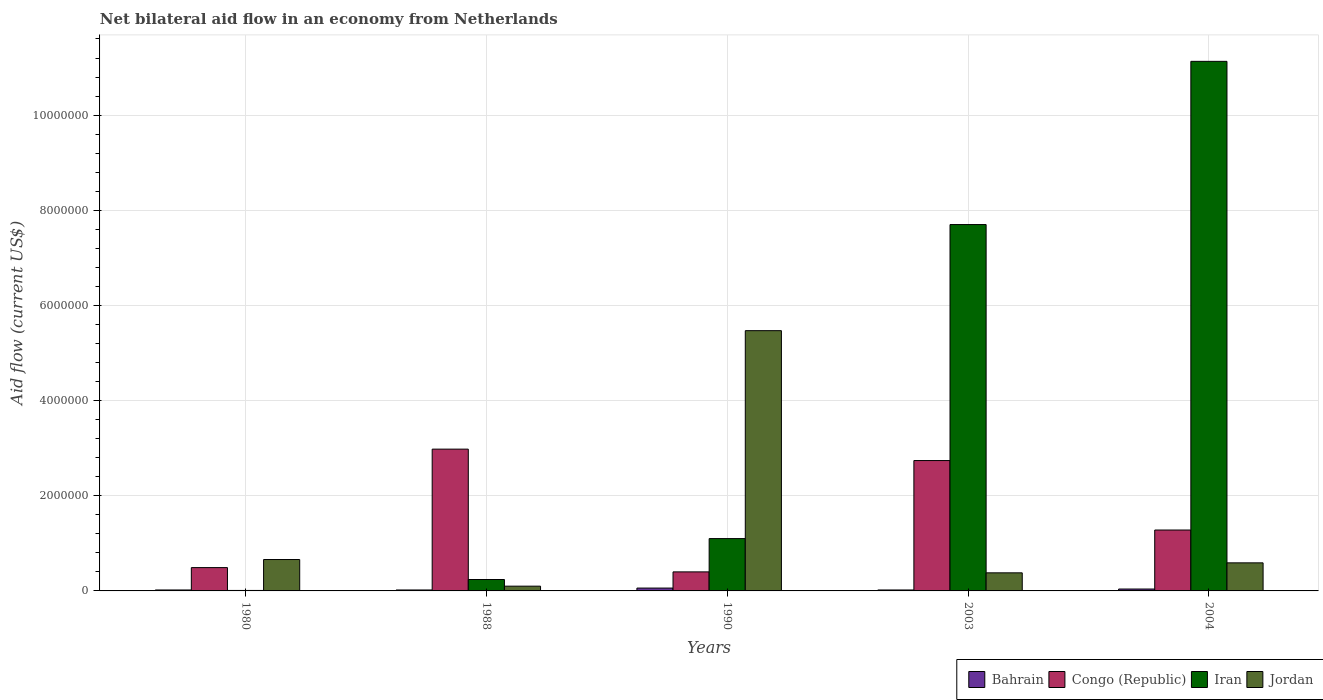How many different coloured bars are there?
Offer a terse response. 4. What is the net bilateral aid flow in Congo (Republic) in 2004?
Make the answer very short. 1.28e+06. Across all years, what is the maximum net bilateral aid flow in Congo (Republic)?
Ensure brevity in your answer.  2.98e+06. Across all years, what is the minimum net bilateral aid flow in Jordan?
Your response must be concise. 1.00e+05. In which year was the net bilateral aid flow in Iran maximum?
Keep it short and to the point. 2004. In which year was the net bilateral aid flow in Jordan minimum?
Give a very brief answer. 1988. What is the total net bilateral aid flow in Jordan in the graph?
Your answer should be very brief. 7.20e+06. What is the difference between the net bilateral aid flow in Jordan in 1990 and that in 2004?
Your answer should be very brief. 4.88e+06. What is the difference between the net bilateral aid flow in Iran in 1980 and the net bilateral aid flow in Jordan in 1990?
Offer a very short reply. -5.46e+06. What is the average net bilateral aid flow in Congo (Republic) per year?
Your response must be concise. 1.58e+06. In the year 2004, what is the difference between the net bilateral aid flow in Congo (Republic) and net bilateral aid flow in Bahrain?
Make the answer very short. 1.24e+06. What is the ratio of the net bilateral aid flow in Jordan in 1988 to that in 1990?
Your answer should be compact. 0.02. What is the difference between the highest and the second highest net bilateral aid flow in Jordan?
Offer a very short reply. 4.81e+06. What is the difference between the highest and the lowest net bilateral aid flow in Jordan?
Provide a succinct answer. 5.37e+06. In how many years, is the net bilateral aid flow in Bahrain greater than the average net bilateral aid flow in Bahrain taken over all years?
Offer a terse response. 2. Is the sum of the net bilateral aid flow in Congo (Republic) in 2003 and 2004 greater than the maximum net bilateral aid flow in Iran across all years?
Your response must be concise. No. What does the 2nd bar from the left in 2004 represents?
Your response must be concise. Congo (Republic). What does the 4th bar from the right in 1988 represents?
Your answer should be very brief. Bahrain. Is it the case that in every year, the sum of the net bilateral aid flow in Iran and net bilateral aid flow in Congo (Republic) is greater than the net bilateral aid flow in Bahrain?
Your answer should be very brief. Yes. How many bars are there?
Keep it short and to the point. 20. How many years are there in the graph?
Your response must be concise. 5. What is the difference between two consecutive major ticks on the Y-axis?
Your answer should be very brief. 2.00e+06. How many legend labels are there?
Your answer should be compact. 4. How are the legend labels stacked?
Provide a succinct answer. Horizontal. What is the title of the graph?
Provide a short and direct response. Net bilateral aid flow in an economy from Netherlands. What is the Aid flow (current US$) of Congo (Republic) in 1988?
Offer a terse response. 2.98e+06. What is the Aid flow (current US$) of Jordan in 1988?
Provide a succinct answer. 1.00e+05. What is the Aid flow (current US$) of Bahrain in 1990?
Your response must be concise. 6.00e+04. What is the Aid flow (current US$) of Iran in 1990?
Offer a very short reply. 1.10e+06. What is the Aid flow (current US$) of Jordan in 1990?
Keep it short and to the point. 5.47e+06. What is the Aid flow (current US$) of Congo (Republic) in 2003?
Offer a terse response. 2.74e+06. What is the Aid flow (current US$) of Iran in 2003?
Offer a terse response. 7.70e+06. What is the Aid flow (current US$) in Bahrain in 2004?
Your answer should be compact. 4.00e+04. What is the Aid flow (current US$) in Congo (Republic) in 2004?
Offer a very short reply. 1.28e+06. What is the Aid flow (current US$) in Iran in 2004?
Offer a terse response. 1.11e+07. What is the Aid flow (current US$) of Jordan in 2004?
Ensure brevity in your answer.  5.90e+05. Across all years, what is the maximum Aid flow (current US$) in Bahrain?
Provide a short and direct response. 6.00e+04. Across all years, what is the maximum Aid flow (current US$) of Congo (Republic)?
Offer a terse response. 2.98e+06. Across all years, what is the maximum Aid flow (current US$) in Iran?
Keep it short and to the point. 1.11e+07. Across all years, what is the maximum Aid flow (current US$) in Jordan?
Give a very brief answer. 5.47e+06. Across all years, what is the minimum Aid flow (current US$) in Congo (Republic)?
Keep it short and to the point. 4.00e+05. Across all years, what is the minimum Aid flow (current US$) of Jordan?
Offer a terse response. 1.00e+05. What is the total Aid flow (current US$) of Bahrain in the graph?
Your response must be concise. 1.60e+05. What is the total Aid flow (current US$) in Congo (Republic) in the graph?
Your answer should be compact. 7.89e+06. What is the total Aid flow (current US$) of Iran in the graph?
Provide a succinct answer. 2.02e+07. What is the total Aid flow (current US$) in Jordan in the graph?
Make the answer very short. 7.20e+06. What is the difference between the Aid flow (current US$) in Bahrain in 1980 and that in 1988?
Your answer should be very brief. 0. What is the difference between the Aid flow (current US$) of Congo (Republic) in 1980 and that in 1988?
Offer a terse response. -2.49e+06. What is the difference between the Aid flow (current US$) in Iran in 1980 and that in 1988?
Offer a terse response. -2.30e+05. What is the difference between the Aid flow (current US$) of Jordan in 1980 and that in 1988?
Offer a terse response. 5.60e+05. What is the difference between the Aid flow (current US$) of Iran in 1980 and that in 1990?
Make the answer very short. -1.09e+06. What is the difference between the Aid flow (current US$) in Jordan in 1980 and that in 1990?
Your response must be concise. -4.81e+06. What is the difference between the Aid flow (current US$) of Bahrain in 1980 and that in 2003?
Keep it short and to the point. 0. What is the difference between the Aid flow (current US$) in Congo (Republic) in 1980 and that in 2003?
Make the answer very short. -2.25e+06. What is the difference between the Aid flow (current US$) of Iran in 1980 and that in 2003?
Make the answer very short. -7.69e+06. What is the difference between the Aid flow (current US$) in Congo (Republic) in 1980 and that in 2004?
Keep it short and to the point. -7.90e+05. What is the difference between the Aid flow (current US$) of Iran in 1980 and that in 2004?
Provide a short and direct response. -1.11e+07. What is the difference between the Aid flow (current US$) in Jordan in 1980 and that in 2004?
Make the answer very short. 7.00e+04. What is the difference between the Aid flow (current US$) of Bahrain in 1988 and that in 1990?
Ensure brevity in your answer.  -4.00e+04. What is the difference between the Aid flow (current US$) of Congo (Republic) in 1988 and that in 1990?
Your response must be concise. 2.58e+06. What is the difference between the Aid flow (current US$) of Iran in 1988 and that in 1990?
Keep it short and to the point. -8.60e+05. What is the difference between the Aid flow (current US$) of Jordan in 1988 and that in 1990?
Offer a terse response. -5.37e+06. What is the difference between the Aid flow (current US$) of Bahrain in 1988 and that in 2003?
Give a very brief answer. 0. What is the difference between the Aid flow (current US$) in Iran in 1988 and that in 2003?
Offer a terse response. -7.46e+06. What is the difference between the Aid flow (current US$) of Jordan in 1988 and that in 2003?
Make the answer very short. -2.80e+05. What is the difference between the Aid flow (current US$) of Bahrain in 1988 and that in 2004?
Offer a very short reply. -2.00e+04. What is the difference between the Aid flow (current US$) in Congo (Republic) in 1988 and that in 2004?
Keep it short and to the point. 1.70e+06. What is the difference between the Aid flow (current US$) of Iran in 1988 and that in 2004?
Your answer should be very brief. -1.09e+07. What is the difference between the Aid flow (current US$) in Jordan in 1988 and that in 2004?
Your response must be concise. -4.90e+05. What is the difference between the Aid flow (current US$) in Bahrain in 1990 and that in 2003?
Keep it short and to the point. 4.00e+04. What is the difference between the Aid flow (current US$) of Congo (Republic) in 1990 and that in 2003?
Give a very brief answer. -2.34e+06. What is the difference between the Aid flow (current US$) of Iran in 1990 and that in 2003?
Offer a terse response. -6.60e+06. What is the difference between the Aid flow (current US$) in Jordan in 1990 and that in 2003?
Offer a very short reply. 5.09e+06. What is the difference between the Aid flow (current US$) in Congo (Republic) in 1990 and that in 2004?
Your answer should be very brief. -8.80e+05. What is the difference between the Aid flow (current US$) in Iran in 1990 and that in 2004?
Provide a short and direct response. -1.00e+07. What is the difference between the Aid flow (current US$) in Jordan in 1990 and that in 2004?
Provide a short and direct response. 4.88e+06. What is the difference between the Aid flow (current US$) in Congo (Republic) in 2003 and that in 2004?
Your response must be concise. 1.46e+06. What is the difference between the Aid flow (current US$) of Iran in 2003 and that in 2004?
Ensure brevity in your answer.  -3.43e+06. What is the difference between the Aid flow (current US$) of Jordan in 2003 and that in 2004?
Ensure brevity in your answer.  -2.10e+05. What is the difference between the Aid flow (current US$) in Bahrain in 1980 and the Aid flow (current US$) in Congo (Republic) in 1988?
Provide a succinct answer. -2.96e+06. What is the difference between the Aid flow (current US$) of Bahrain in 1980 and the Aid flow (current US$) of Iran in 1988?
Your answer should be very brief. -2.20e+05. What is the difference between the Aid flow (current US$) of Bahrain in 1980 and the Aid flow (current US$) of Jordan in 1988?
Ensure brevity in your answer.  -8.00e+04. What is the difference between the Aid flow (current US$) of Bahrain in 1980 and the Aid flow (current US$) of Congo (Republic) in 1990?
Your response must be concise. -3.80e+05. What is the difference between the Aid flow (current US$) of Bahrain in 1980 and the Aid flow (current US$) of Iran in 1990?
Offer a very short reply. -1.08e+06. What is the difference between the Aid flow (current US$) in Bahrain in 1980 and the Aid flow (current US$) in Jordan in 1990?
Provide a succinct answer. -5.45e+06. What is the difference between the Aid flow (current US$) in Congo (Republic) in 1980 and the Aid flow (current US$) in Iran in 1990?
Your answer should be very brief. -6.10e+05. What is the difference between the Aid flow (current US$) in Congo (Republic) in 1980 and the Aid flow (current US$) in Jordan in 1990?
Make the answer very short. -4.98e+06. What is the difference between the Aid flow (current US$) in Iran in 1980 and the Aid flow (current US$) in Jordan in 1990?
Provide a succinct answer. -5.46e+06. What is the difference between the Aid flow (current US$) of Bahrain in 1980 and the Aid flow (current US$) of Congo (Republic) in 2003?
Give a very brief answer. -2.72e+06. What is the difference between the Aid flow (current US$) in Bahrain in 1980 and the Aid flow (current US$) in Iran in 2003?
Offer a terse response. -7.68e+06. What is the difference between the Aid flow (current US$) of Bahrain in 1980 and the Aid flow (current US$) of Jordan in 2003?
Offer a very short reply. -3.60e+05. What is the difference between the Aid flow (current US$) of Congo (Republic) in 1980 and the Aid flow (current US$) of Iran in 2003?
Provide a short and direct response. -7.21e+06. What is the difference between the Aid flow (current US$) of Iran in 1980 and the Aid flow (current US$) of Jordan in 2003?
Your answer should be very brief. -3.70e+05. What is the difference between the Aid flow (current US$) in Bahrain in 1980 and the Aid flow (current US$) in Congo (Republic) in 2004?
Give a very brief answer. -1.26e+06. What is the difference between the Aid flow (current US$) of Bahrain in 1980 and the Aid flow (current US$) of Iran in 2004?
Offer a terse response. -1.11e+07. What is the difference between the Aid flow (current US$) in Bahrain in 1980 and the Aid flow (current US$) in Jordan in 2004?
Your answer should be compact. -5.70e+05. What is the difference between the Aid flow (current US$) of Congo (Republic) in 1980 and the Aid flow (current US$) of Iran in 2004?
Provide a short and direct response. -1.06e+07. What is the difference between the Aid flow (current US$) of Congo (Republic) in 1980 and the Aid flow (current US$) of Jordan in 2004?
Give a very brief answer. -1.00e+05. What is the difference between the Aid flow (current US$) of Iran in 1980 and the Aid flow (current US$) of Jordan in 2004?
Ensure brevity in your answer.  -5.80e+05. What is the difference between the Aid flow (current US$) of Bahrain in 1988 and the Aid flow (current US$) of Congo (Republic) in 1990?
Offer a terse response. -3.80e+05. What is the difference between the Aid flow (current US$) of Bahrain in 1988 and the Aid flow (current US$) of Iran in 1990?
Make the answer very short. -1.08e+06. What is the difference between the Aid flow (current US$) in Bahrain in 1988 and the Aid flow (current US$) in Jordan in 1990?
Your response must be concise. -5.45e+06. What is the difference between the Aid flow (current US$) in Congo (Republic) in 1988 and the Aid flow (current US$) in Iran in 1990?
Keep it short and to the point. 1.88e+06. What is the difference between the Aid flow (current US$) of Congo (Republic) in 1988 and the Aid flow (current US$) of Jordan in 1990?
Keep it short and to the point. -2.49e+06. What is the difference between the Aid flow (current US$) in Iran in 1988 and the Aid flow (current US$) in Jordan in 1990?
Your answer should be compact. -5.23e+06. What is the difference between the Aid flow (current US$) in Bahrain in 1988 and the Aid flow (current US$) in Congo (Republic) in 2003?
Ensure brevity in your answer.  -2.72e+06. What is the difference between the Aid flow (current US$) in Bahrain in 1988 and the Aid flow (current US$) in Iran in 2003?
Ensure brevity in your answer.  -7.68e+06. What is the difference between the Aid flow (current US$) in Bahrain in 1988 and the Aid flow (current US$) in Jordan in 2003?
Offer a terse response. -3.60e+05. What is the difference between the Aid flow (current US$) in Congo (Republic) in 1988 and the Aid flow (current US$) in Iran in 2003?
Give a very brief answer. -4.72e+06. What is the difference between the Aid flow (current US$) of Congo (Republic) in 1988 and the Aid flow (current US$) of Jordan in 2003?
Make the answer very short. 2.60e+06. What is the difference between the Aid flow (current US$) in Iran in 1988 and the Aid flow (current US$) in Jordan in 2003?
Your response must be concise. -1.40e+05. What is the difference between the Aid flow (current US$) of Bahrain in 1988 and the Aid flow (current US$) of Congo (Republic) in 2004?
Your answer should be compact. -1.26e+06. What is the difference between the Aid flow (current US$) in Bahrain in 1988 and the Aid flow (current US$) in Iran in 2004?
Give a very brief answer. -1.11e+07. What is the difference between the Aid flow (current US$) of Bahrain in 1988 and the Aid flow (current US$) of Jordan in 2004?
Your response must be concise. -5.70e+05. What is the difference between the Aid flow (current US$) in Congo (Republic) in 1988 and the Aid flow (current US$) in Iran in 2004?
Give a very brief answer. -8.15e+06. What is the difference between the Aid flow (current US$) of Congo (Republic) in 1988 and the Aid flow (current US$) of Jordan in 2004?
Your response must be concise. 2.39e+06. What is the difference between the Aid flow (current US$) in Iran in 1988 and the Aid flow (current US$) in Jordan in 2004?
Your answer should be very brief. -3.50e+05. What is the difference between the Aid flow (current US$) in Bahrain in 1990 and the Aid flow (current US$) in Congo (Republic) in 2003?
Ensure brevity in your answer.  -2.68e+06. What is the difference between the Aid flow (current US$) in Bahrain in 1990 and the Aid flow (current US$) in Iran in 2003?
Your answer should be compact. -7.64e+06. What is the difference between the Aid flow (current US$) in Bahrain in 1990 and the Aid flow (current US$) in Jordan in 2003?
Your answer should be very brief. -3.20e+05. What is the difference between the Aid flow (current US$) of Congo (Republic) in 1990 and the Aid flow (current US$) of Iran in 2003?
Ensure brevity in your answer.  -7.30e+06. What is the difference between the Aid flow (current US$) of Congo (Republic) in 1990 and the Aid flow (current US$) of Jordan in 2003?
Ensure brevity in your answer.  2.00e+04. What is the difference between the Aid flow (current US$) of Iran in 1990 and the Aid flow (current US$) of Jordan in 2003?
Keep it short and to the point. 7.20e+05. What is the difference between the Aid flow (current US$) of Bahrain in 1990 and the Aid flow (current US$) of Congo (Republic) in 2004?
Your answer should be compact. -1.22e+06. What is the difference between the Aid flow (current US$) in Bahrain in 1990 and the Aid flow (current US$) in Iran in 2004?
Keep it short and to the point. -1.11e+07. What is the difference between the Aid flow (current US$) in Bahrain in 1990 and the Aid flow (current US$) in Jordan in 2004?
Your answer should be compact. -5.30e+05. What is the difference between the Aid flow (current US$) in Congo (Republic) in 1990 and the Aid flow (current US$) in Iran in 2004?
Offer a terse response. -1.07e+07. What is the difference between the Aid flow (current US$) in Iran in 1990 and the Aid flow (current US$) in Jordan in 2004?
Keep it short and to the point. 5.10e+05. What is the difference between the Aid flow (current US$) of Bahrain in 2003 and the Aid flow (current US$) of Congo (Republic) in 2004?
Provide a succinct answer. -1.26e+06. What is the difference between the Aid flow (current US$) of Bahrain in 2003 and the Aid flow (current US$) of Iran in 2004?
Give a very brief answer. -1.11e+07. What is the difference between the Aid flow (current US$) in Bahrain in 2003 and the Aid flow (current US$) in Jordan in 2004?
Offer a terse response. -5.70e+05. What is the difference between the Aid flow (current US$) of Congo (Republic) in 2003 and the Aid flow (current US$) of Iran in 2004?
Offer a terse response. -8.39e+06. What is the difference between the Aid flow (current US$) in Congo (Republic) in 2003 and the Aid flow (current US$) in Jordan in 2004?
Your response must be concise. 2.15e+06. What is the difference between the Aid flow (current US$) of Iran in 2003 and the Aid flow (current US$) of Jordan in 2004?
Make the answer very short. 7.11e+06. What is the average Aid flow (current US$) of Bahrain per year?
Give a very brief answer. 3.20e+04. What is the average Aid flow (current US$) in Congo (Republic) per year?
Keep it short and to the point. 1.58e+06. What is the average Aid flow (current US$) of Iran per year?
Give a very brief answer. 4.04e+06. What is the average Aid flow (current US$) in Jordan per year?
Keep it short and to the point. 1.44e+06. In the year 1980, what is the difference between the Aid flow (current US$) in Bahrain and Aid flow (current US$) in Congo (Republic)?
Make the answer very short. -4.70e+05. In the year 1980, what is the difference between the Aid flow (current US$) in Bahrain and Aid flow (current US$) in Jordan?
Ensure brevity in your answer.  -6.40e+05. In the year 1980, what is the difference between the Aid flow (current US$) in Congo (Republic) and Aid flow (current US$) in Iran?
Ensure brevity in your answer.  4.80e+05. In the year 1980, what is the difference between the Aid flow (current US$) of Iran and Aid flow (current US$) of Jordan?
Your response must be concise. -6.50e+05. In the year 1988, what is the difference between the Aid flow (current US$) in Bahrain and Aid flow (current US$) in Congo (Republic)?
Ensure brevity in your answer.  -2.96e+06. In the year 1988, what is the difference between the Aid flow (current US$) of Bahrain and Aid flow (current US$) of Iran?
Provide a short and direct response. -2.20e+05. In the year 1988, what is the difference between the Aid flow (current US$) in Bahrain and Aid flow (current US$) in Jordan?
Your answer should be very brief. -8.00e+04. In the year 1988, what is the difference between the Aid flow (current US$) in Congo (Republic) and Aid flow (current US$) in Iran?
Offer a terse response. 2.74e+06. In the year 1988, what is the difference between the Aid flow (current US$) of Congo (Republic) and Aid flow (current US$) of Jordan?
Offer a terse response. 2.88e+06. In the year 1990, what is the difference between the Aid flow (current US$) in Bahrain and Aid flow (current US$) in Iran?
Make the answer very short. -1.04e+06. In the year 1990, what is the difference between the Aid flow (current US$) in Bahrain and Aid flow (current US$) in Jordan?
Offer a very short reply. -5.41e+06. In the year 1990, what is the difference between the Aid flow (current US$) of Congo (Republic) and Aid flow (current US$) of Iran?
Keep it short and to the point. -7.00e+05. In the year 1990, what is the difference between the Aid flow (current US$) in Congo (Republic) and Aid flow (current US$) in Jordan?
Keep it short and to the point. -5.07e+06. In the year 1990, what is the difference between the Aid flow (current US$) of Iran and Aid flow (current US$) of Jordan?
Ensure brevity in your answer.  -4.37e+06. In the year 2003, what is the difference between the Aid flow (current US$) of Bahrain and Aid flow (current US$) of Congo (Republic)?
Your answer should be compact. -2.72e+06. In the year 2003, what is the difference between the Aid flow (current US$) of Bahrain and Aid flow (current US$) of Iran?
Ensure brevity in your answer.  -7.68e+06. In the year 2003, what is the difference between the Aid flow (current US$) of Bahrain and Aid flow (current US$) of Jordan?
Give a very brief answer. -3.60e+05. In the year 2003, what is the difference between the Aid flow (current US$) in Congo (Republic) and Aid flow (current US$) in Iran?
Ensure brevity in your answer.  -4.96e+06. In the year 2003, what is the difference between the Aid flow (current US$) in Congo (Republic) and Aid flow (current US$) in Jordan?
Offer a terse response. 2.36e+06. In the year 2003, what is the difference between the Aid flow (current US$) of Iran and Aid flow (current US$) of Jordan?
Your answer should be very brief. 7.32e+06. In the year 2004, what is the difference between the Aid flow (current US$) in Bahrain and Aid flow (current US$) in Congo (Republic)?
Your response must be concise. -1.24e+06. In the year 2004, what is the difference between the Aid flow (current US$) of Bahrain and Aid flow (current US$) of Iran?
Provide a short and direct response. -1.11e+07. In the year 2004, what is the difference between the Aid flow (current US$) in Bahrain and Aid flow (current US$) in Jordan?
Your response must be concise. -5.50e+05. In the year 2004, what is the difference between the Aid flow (current US$) in Congo (Republic) and Aid flow (current US$) in Iran?
Offer a very short reply. -9.85e+06. In the year 2004, what is the difference between the Aid flow (current US$) in Congo (Republic) and Aid flow (current US$) in Jordan?
Offer a very short reply. 6.90e+05. In the year 2004, what is the difference between the Aid flow (current US$) of Iran and Aid flow (current US$) of Jordan?
Your response must be concise. 1.05e+07. What is the ratio of the Aid flow (current US$) in Congo (Republic) in 1980 to that in 1988?
Your answer should be very brief. 0.16. What is the ratio of the Aid flow (current US$) of Iran in 1980 to that in 1988?
Your answer should be very brief. 0.04. What is the ratio of the Aid flow (current US$) in Bahrain in 1980 to that in 1990?
Your answer should be compact. 0.33. What is the ratio of the Aid flow (current US$) in Congo (Republic) in 1980 to that in 1990?
Offer a very short reply. 1.23. What is the ratio of the Aid flow (current US$) of Iran in 1980 to that in 1990?
Ensure brevity in your answer.  0.01. What is the ratio of the Aid flow (current US$) of Jordan in 1980 to that in 1990?
Your answer should be very brief. 0.12. What is the ratio of the Aid flow (current US$) in Congo (Republic) in 1980 to that in 2003?
Your answer should be very brief. 0.18. What is the ratio of the Aid flow (current US$) of Iran in 1980 to that in 2003?
Offer a terse response. 0. What is the ratio of the Aid flow (current US$) in Jordan in 1980 to that in 2003?
Ensure brevity in your answer.  1.74. What is the ratio of the Aid flow (current US$) in Bahrain in 1980 to that in 2004?
Make the answer very short. 0.5. What is the ratio of the Aid flow (current US$) of Congo (Republic) in 1980 to that in 2004?
Provide a succinct answer. 0.38. What is the ratio of the Aid flow (current US$) in Iran in 1980 to that in 2004?
Make the answer very short. 0. What is the ratio of the Aid flow (current US$) of Jordan in 1980 to that in 2004?
Offer a very short reply. 1.12. What is the ratio of the Aid flow (current US$) in Congo (Republic) in 1988 to that in 1990?
Provide a short and direct response. 7.45. What is the ratio of the Aid flow (current US$) of Iran in 1988 to that in 1990?
Provide a short and direct response. 0.22. What is the ratio of the Aid flow (current US$) of Jordan in 1988 to that in 1990?
Your answer should be very brief. 0.02. What is the ratio of the Aid flow (current US$) of Congo (Republic) in 1988 to that in 2003?
Offer a very short reply. 1.09. What is the ratio of the Aid flow (current US$) of Iran in 1988 to that in 2003?
Keep it short and to the point. 0.03. What is the ratio of the Aid flow (current US$) of Jordan in 1988 to that in 2003?
Give a very brief answer. 0.26. What is the ratio of the Aid flow (current US$) of Congo (Republic) in 1988 to that in 2004?
Ensure brevity in your answer.  2.33. What is the ratio of the Aid flow (current US$) in Iran in 1988 to that in 2004?
Your answer should be compact. 0.02. What is the ratio of the Aid flow (current US$) of Jordan in 1988 to that in 2004?
Make the answer very short. 0.17. What is the ratio of the Aid flow (current US$) in Congo (Republic) in 1990 to that in 2003?
Offer a very short reply. 0.15. What is the ratio of the Aid flow (current US$) in Iran in 1990 to that in 2003?
Offer a very short reply. 0.14. What is the ratio of the Aid flow (current US$) of Jordan in 1990 to that in 2003?
Provide a short and direct response. 14.39. What is the ratio of the Aid flow (current US$) in Bahrain in 1990 to that in 2004?
Offer a very short reply. 1.5. What is the ratio of the Aid flow (current US$) of Congo (Republic) in 1990 to that in 2004?
Offer a very short reply. 0.31. What is the ratio of the Aid flow (current US$) in Iran in 1990 to that in 2004?
Your answer should be compact. 0.1. What is the ratio of the Aid flow (current US$) in Jordan in 1990 to that in 2004?
Provide a succinct answer. 9.27. What is the ratio of the Aid flow (current US$) of Bahrain in 2003 to that in 2004?
Your answer should be compact. 0.5. What is the ratio of the Aid flow (current US$) in Congo (Republic) in 2003 to that in 2004?
Your answer should be very brief. 2.14. What is the ratio of the Aid flow (current US$) of Iran in 2003 to that in 2004?
Your answer should be very brief. 0.69. What is the ratio of the Aid flow (current US$) of Jordan in 2003 to that in 2004?
Your answer should be compact. 0.64. What is the difference between the highest and the second highest Aid flow (current US$) in Bahrain?
Offer a very short reply. 2.00e+04. What is the difference between the highest and the second highest Aid flow (current US$) of Iran?
Make the answer very short. 3.43e+06. What is the difference between the highest and the second highest Aid flow (current US$) of Jordan?
Your response must be concise. 4.81e+06. What is the difference between the highest and the lowest Aid flow (current US$) of Congo (Republic)?
Your response must be concise. 2.58e+06. What is the difference between the highest and the lowest Aid flow (current US$) of Iran?
Give a very brief answer. 1.11e+07. What is the difference between the highest and the lowest Aid flow (current US$) of Jordan?
Provide a short and direct response. 5.37e+06. 